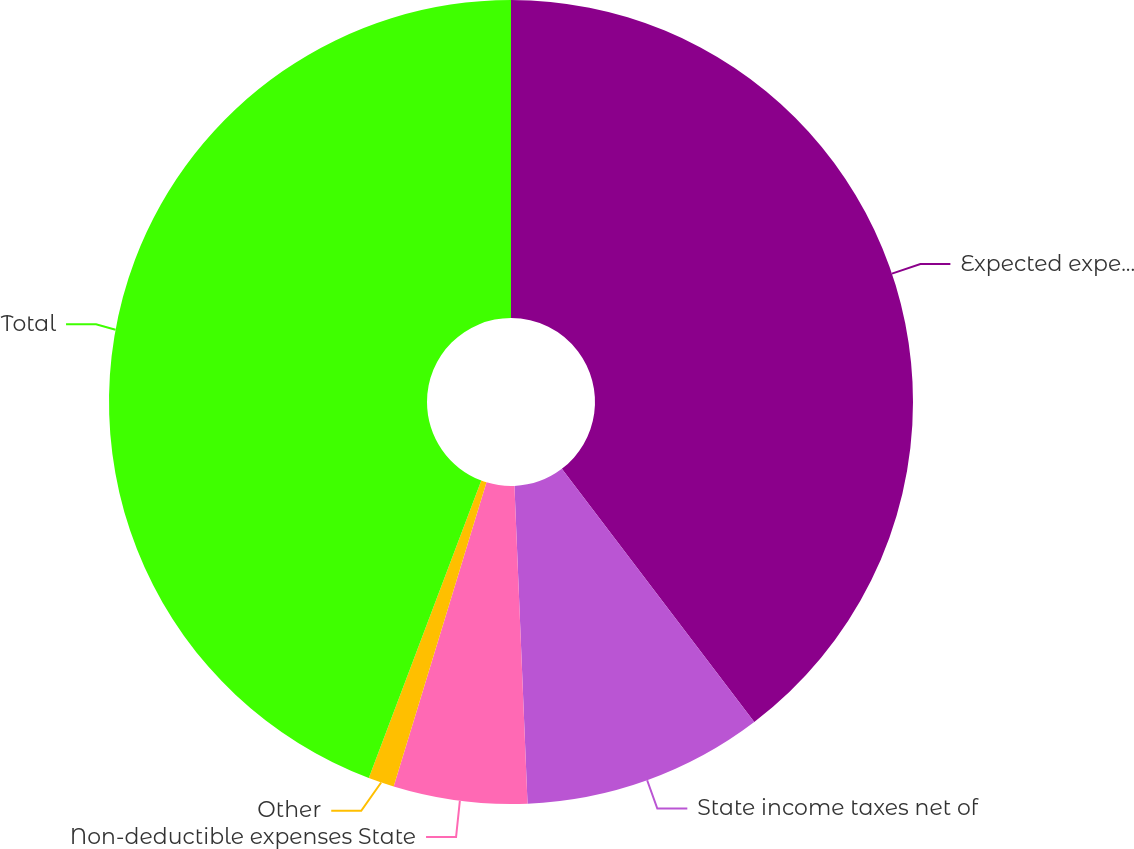Convert chart to OTSL. <chart><loc_0><loc_0><loc_500><loc_500><pie_chart><fcel>Expected expense at statutory<fcel>State income taxes net of<fcel>Non-deductible expenses State<fcel>Other<fcel>Total<nl><fcel>39.66%<fcel>9.69%<fcel>5.37%<fcel>1.04%<fcel>44.25%<nl></chart> 